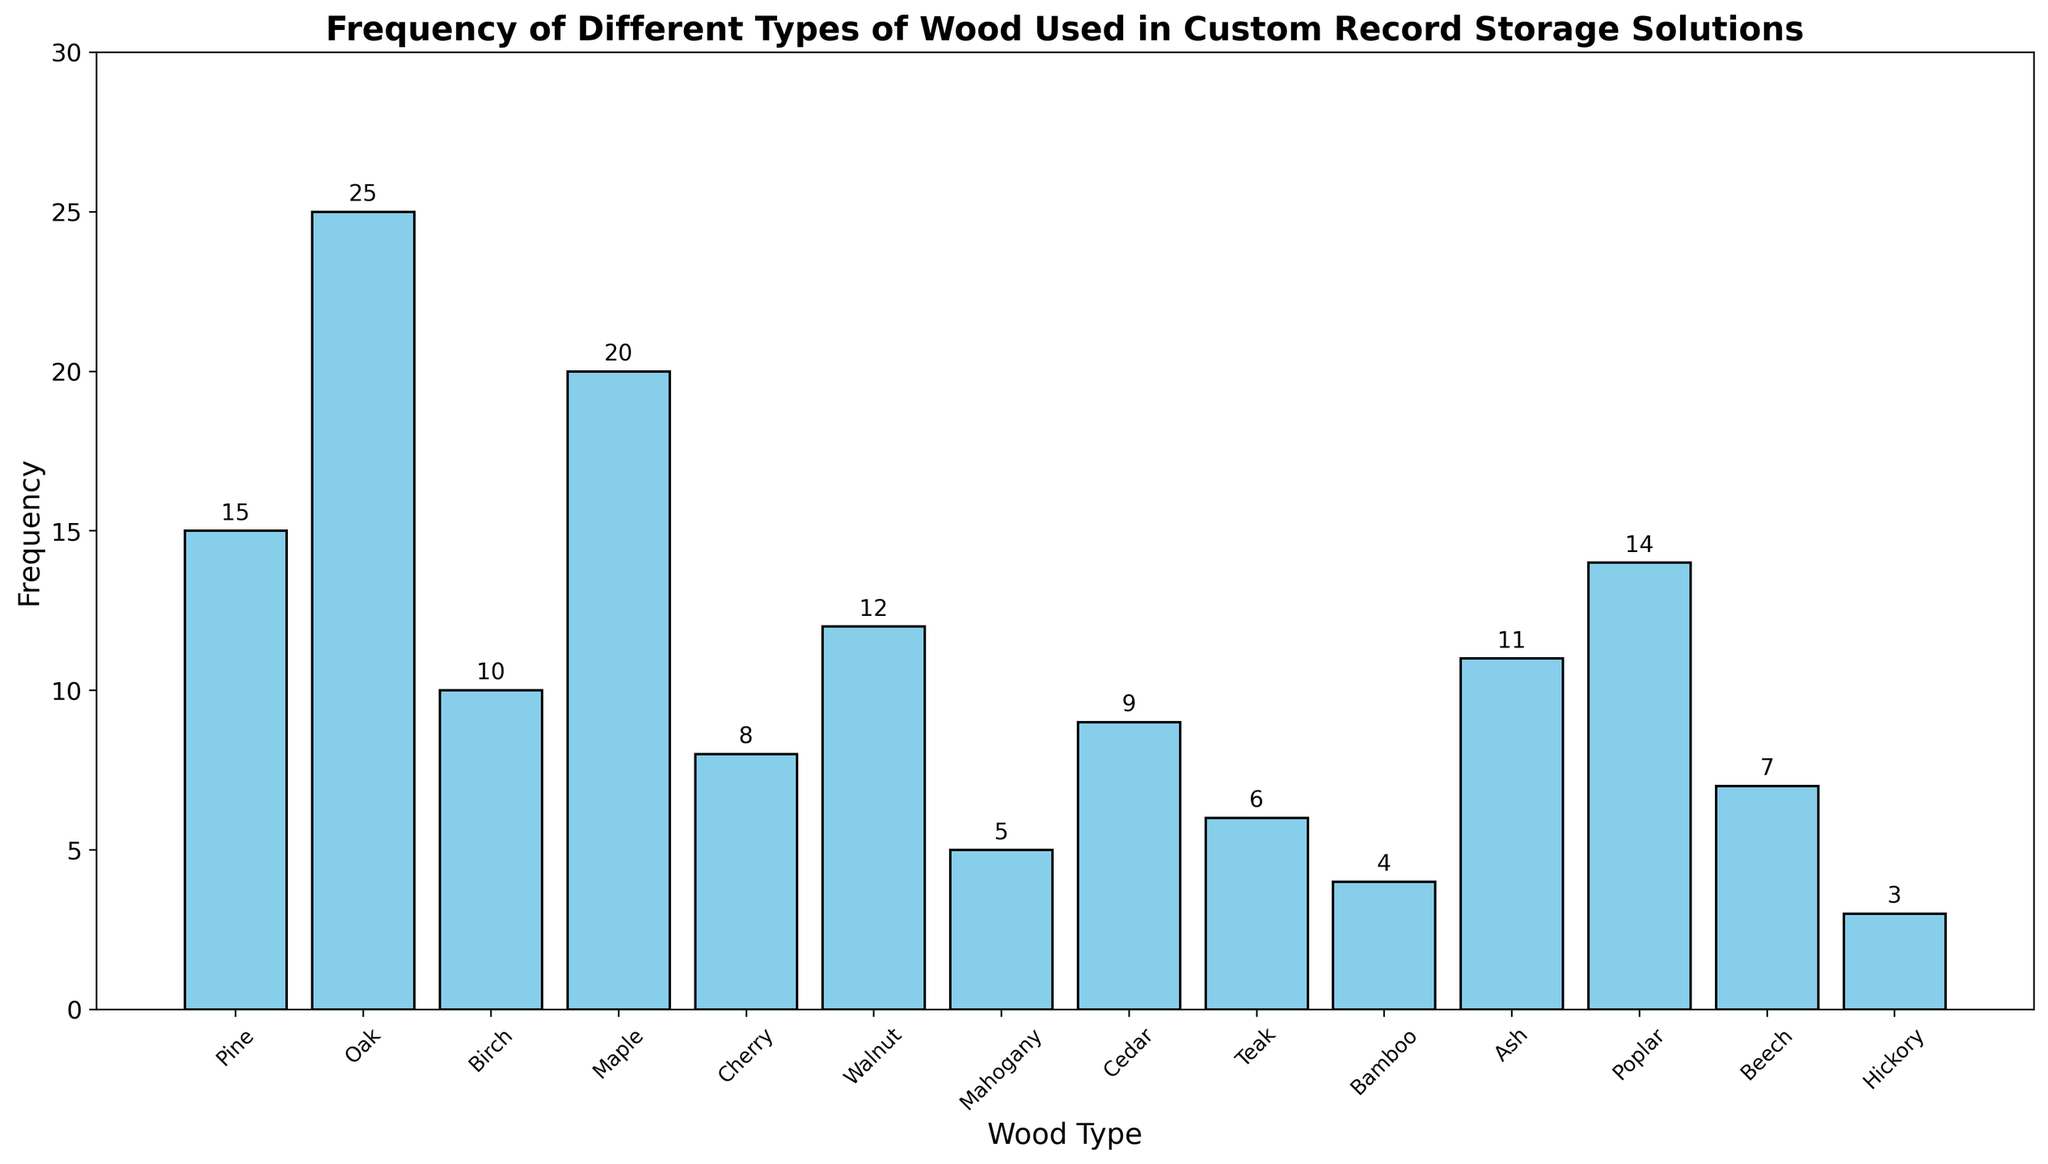Which type of wood is used most frequently in custom record storage solutions? The bar for Oak is the tallest, making it the most frequently used wood type.
Answer: Oak Which wood types have a frequency of less than 10? The wood types with a frequency bar height below 10 are Cherry, Mahogany, Cedar, Teak, Bamboo, Beech, and Hickory.
Answer: Cherry, Mahogany, Cedar, Teak, Bamboo, Beech, Hickory How many wood types have frequencies greater than or equal to 10? By counting the bars with a frequency of 10 or more, we identify Pine, Oak, Birch, Maple, Walnut, Ash, and Poplar.
Answer: 7 What is the combined frequency of Pine and Birch? Pine has a frequency of 15 and Birch has a frequency of 10. Their combined frequency is 15 + 10 = 25.
Answer: 25 Which wood types have a frequency higher than Walnut? Walnut has a frequency of 12. The wood types with higher frequencies are Pine, Oak, Birch, and Maple.
Answer: Pine, Oak, Birch, Maple Which wood type is the least frequently used? The shortest bar corresponds to Hickory with a frequency of 3.
Answer: Hickory How does the frequency of Cherry compare to Cedar? Cherry has a frequency of 8, while Cedar has a frequency of 9. Hence, Cedar is used slightly more frequently than Cherry.
Answer: Cedar > Cherry What is the average frequency of the wood types used? Summing all the frequencies: 15 + 25 + 10 + 20 + 8 + 12 + 5 + 9 + 6 + 4 + 11 + 14 + 7 + 3 = 149. Dividing by the number of wood types (14): 149 / 14 ≈ 10.64.
Answer: ~10.64 How much more frequently is Oak used compared to Maple? Oak has a frequency of 25 and Maple has a frequency of 20. The difference is 25 - 20 = 5.
Answer: 5 What is the median frequency value among the wood types? Sorting the frequencies: 3, 4, 5, 6, 7, 8, 9, 10, 11, 12, 14, 15, 20, 25. The middle values are 9 and 10. The median is (9 + 10) / 2 = 9.5
Answer: 9.5 